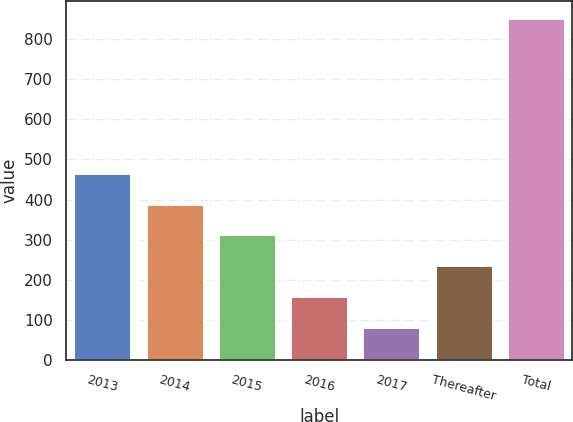Convert chart to OTSL. <chart><loc_0><loc_0><loc_500><loc_500><bar_chart><fcel>2013<fcel>2014<fcel>2015<fcel>2016<fcel>2017<fcel>Thereafter<fcel>Total<nl><fcel>467<fcel>390<fcel>313<fcel>159<fcel>82<fcel>236<fcel>852<nl></chart> 